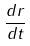Convert formula to latex. <formula><loc_0><loc_0><loc_500><loc_500>\frac { d r } { d t }</formula> 